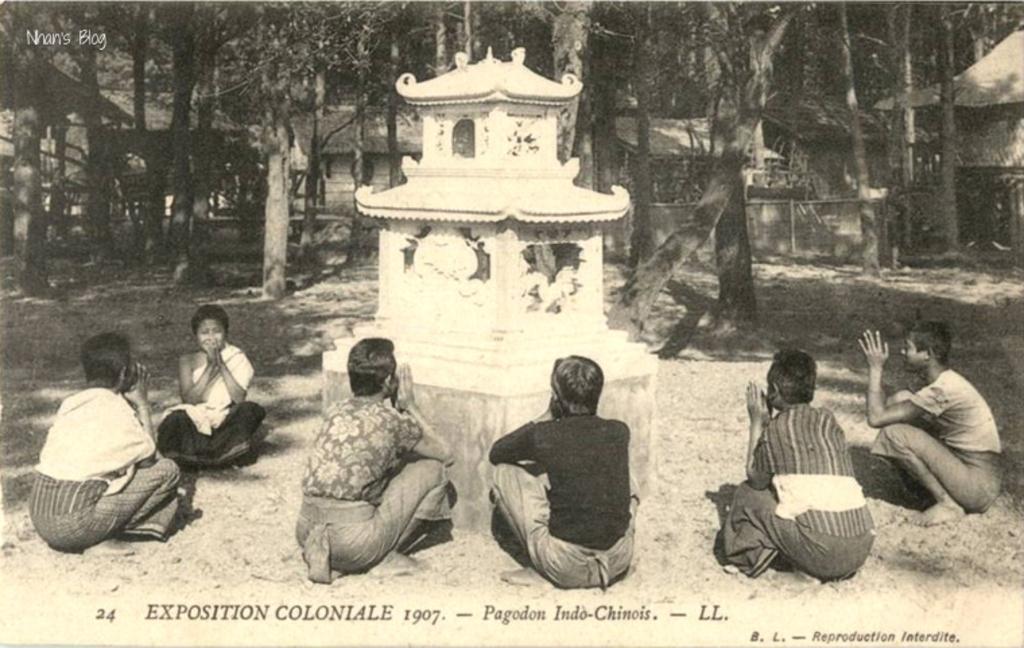In one or two sentences, can you explain what this image depicts? In this image we can see the black and white image and there are few people sitting and in the middle there is a structure which looks like a statue. In the background, we can see some trees and huts. 